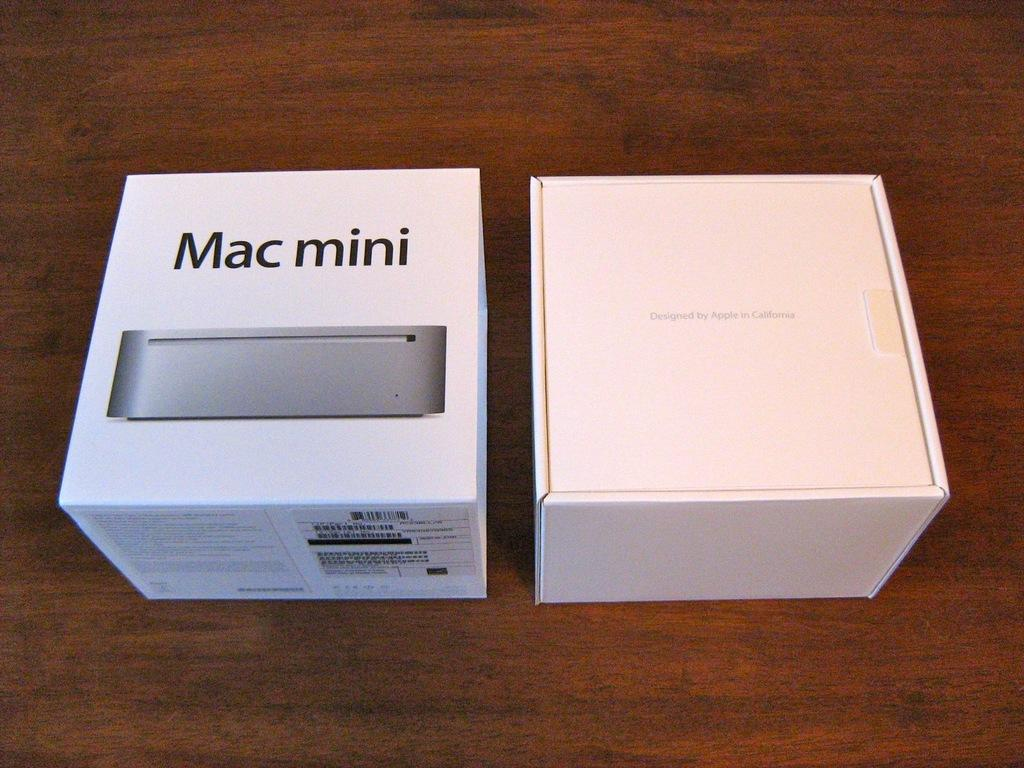Provide a one-sentence caption for the provided image. Two small square boxes with one Mac Mini and the other with the other from Apple. 